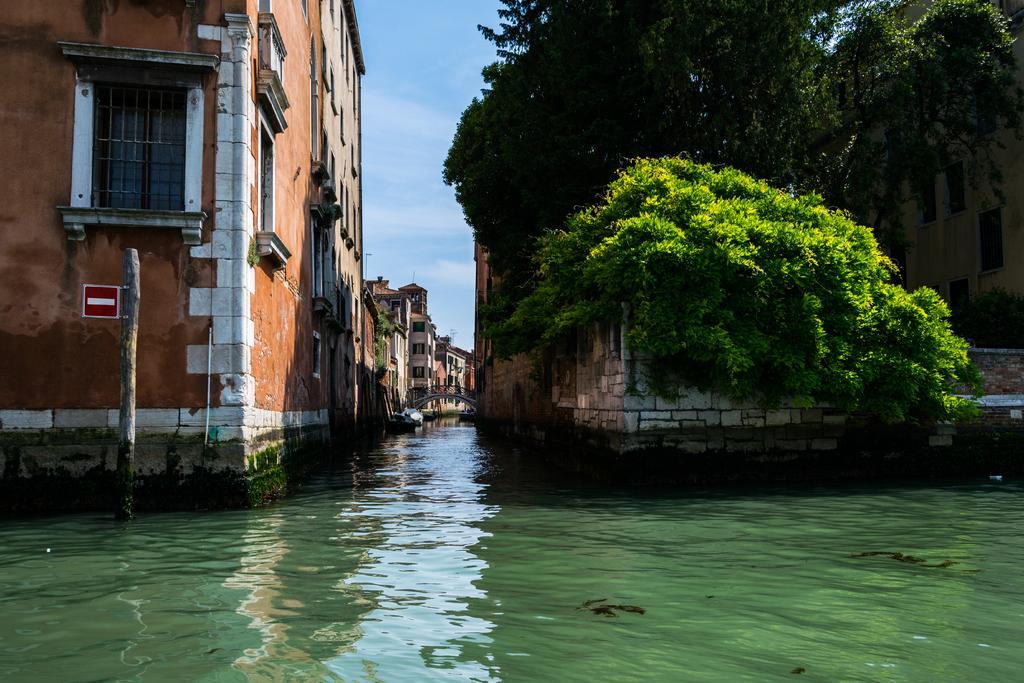How would you summarize this image in a sentence or two? As we can see in the image there is water, buildings, windows, trees and at the top there is sky. 